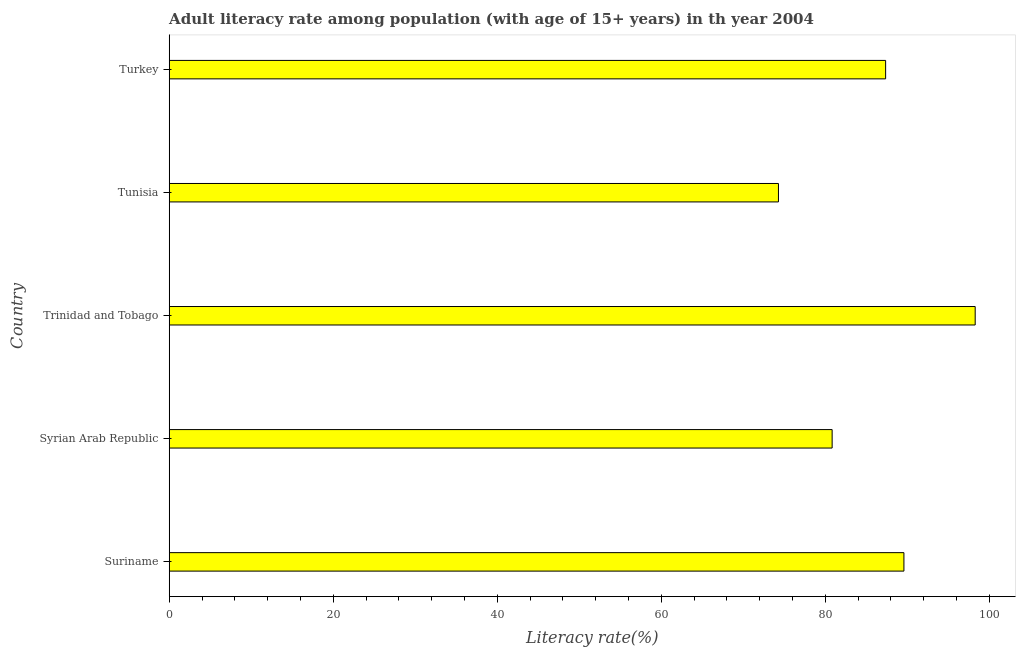Does the graph contain any zero values?
Your answer should be compact. No. What is the title of the graph?
Keep it short and to the point. Adult literacy rate among population (with age of 15+ years) in th year 2004. What is the label or title of the X-axis?
Make the answer very short. Literacy rate(%). What is the label or title of the Y-axis?
Offer a very short reply. Country. What is the adult literacy rate in Tunisia?
Offer a very short reply. 74.3. Across all countries, what is the maximum adult literacy rate?
Your answer should be compact. 98.29. Across all countries, what is the minimum adult literacy rate?
Ensure brevity in your answer.  74.3. In which country was the adult literacy rate maximum?
Offer a terse response. Trinidad and Tobago. In which country was the adult literacy rate minimum?
Ensure brevity in your answer.  Tunisia. What is the sum of the adult literacy rate?
Ensure brevity in your answer.  430.39. What is the difference between the adult literacy rate in Tunisia and Turkey?
Give a very brief answer. -13.07. What is the average adult literacy rate per country?
Provide a short and direct response. 86.08. What is the median adult literacy rate?
Ensure brevity in your answer.  87.37. What is the ratio of the adult literacy rate in Suriname to that in Tunisia?
Offer a terse response. 1.21. Is the adult literacy rate in Suriname less than that in Turkey?
Keep it short and to the point. No. What is the difference between the highest and the second highest adult literacy rate?
Make the answer very short. 8.69. Is the sum of the adult literacy rate in Syrian Arab Republic and Tunisia greater than the maximum adult literacy rate across all countries?
Offer a very short reply. Yes. What is the difference between the highest and the lowest adult literacy rate?
Your answer should be compact. 23.99. In how many countries, is the adult literacy rate greater than the average adult literacy rate taken over all countries?
Your answer should be very brief. 3. How many bars are there?
Ensure brevity in your answer.  5. Are all the bars in the graph horizontal?
Keep it short and to the point. Yes. How many countries are there in the graph?
Give a very brief answer. 5. Are the values on the major ticks of X-axis written in scientific E-notation?
Provide a succinct answer. No. What is the Literacy rate(%) in Suriname?
Keep it short and to the point. 89.6. What is the Literacy rate(%) of Syrian Arab Republic?
Your response must be concise. 80.84. What is the Literacy rate(%) of Trinidad and Tobago?
Make the answer very short. 98.29. What is the Literacy rate(%) of Tunisia?
Keep it short and to the point. 74.3. What is the Literacy rate(%) of Turkey?
Provide a short and direct response. 87.37. What is the difference between the Literacy rate(%) in Suriname and Syrian Arab Republic?
Your response must be concise. 8.75. What is the difference between the Literacy rate(%) in Suriname and Trinidad and Tobago?
Keep it short and to the point. -8.69. What is the difference between the Literacy rate(%) in Suriname and Tunisia?
Your answer should be very brief. 15.3. What is the difference between the Literacy rate(%) in Suriname and Turkey?
Ensure brevity in your answer.  2.23. What is the difference between the Literacy rate(%) in Syrian Arab Republic and Trinidad and Tobago?
Keep it short and to the point. -17.44. What is the difference between the Literacy rate(%) in Syrian Arab Republic and Tunisia?
Give a very brief answer. 6.55. What is the difference between the Literacy rate(%) in Syrian Arab Republic and Turkey?
Your response must be concise. -6.52. What is the difference between the Literacy rate(%) in Trinidad and Tobago and Tunisia?
Keep it short and to the point. 23.99. What is the difference between the Literacy rate(%) in Trinidad and Tobago and Turkey?
Make the answer very short. 10.92. What is the difference between the Literacy rate(%) in Tunisia and Turkey?
Your response must be concise. -13.07. What is the ratio of the Literacy rate(%) in Suriname to that in Syrian Arab Republic?
Provide a short and direct response. 1.11. What is the ratio of the Literacy rate(%) in Suriname to that in Trinidad and Tobago?
Your response must be concise. 0.91. What is the ratio of the Literacy rate(%) in Suriname to that in Tunisia?
Offer a very short reply. 1.21. What is the ratio of the Literacy rate(%) in Syrian Arab Republic to that in Trinidad and Tobago?
Ensure brevity in your answer.  0.82. What is the ratio of the Literacy rate(%) in Syrian Arab Republic to that in Tunisia?
Give a very brief answer. 1.09. What is the ratio of the Literacy rate(%) in Syrian Arab Republic to that in Turkey?
Your answer should be compact. 0.93. What is the ratio of the Literacy rate(%) in Trinidad and Tobago to that in Tunisia?
Your response must be concise. 1.32. What is the ratio of the Literacy rate(%) in Trinidad and Tobago to that in Turkey?
Make the answer very short. 1.12. What is the ratio of the Literacy rate(%) in Tunisia to that in Turkey?
Ensure brevity in your answer.  0.85. 